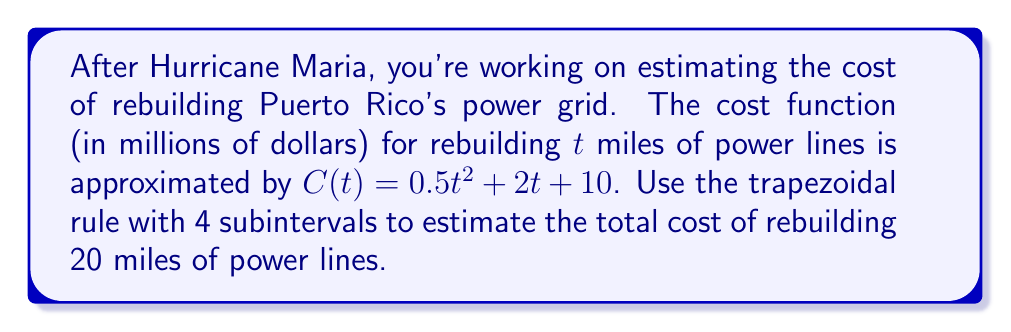Can you answer this question? 1) The trapezoidal rule for numerical integration is given by:

   $$\int_{a}^{b} f(x) dx \approx \frac{h}{2}[f(x_0) + 2f(x_1) + 2f(x_2) + ... + 2f(x_{n-1}) + f(x_n)]$$

   where $h = \frac{b-a}{n}$, and $n$ is the number of subintervals.

2) In this case, $a=0$, $b=20$, and $n=4$. So, $h = \frac{20-0}{4} = 5$.

3) We need to calculate $C(t)$ at $t = 0, 5, 10, 15, 20$:

   $C(0) = 0.5(0)^2 + 2(0) + 10 = 10$
   $C(5) = 0.5(5)^2 + 2(5) + 10 = 32.5$
   $C(10) = 0.5(10)^2 + 2(10) + 10 = 80$
   $C(15) = 0.5(15)^2 + 2(15) + 10 = 152.5$
   $C(20) = 0.5(20)^2 + 2(20) + 10 = 250$

4) Applying the trapezoidal rule:

   $$\text{Total Cost} \approx \frac{5}{2}[10 + 2(32.5) + 2(80) + 2(152.5) + 250]$$

5) Simplifying:
   $$\text{Total Cost} \approx \frac{5}{2}[10 + 65 + 160 + 305 + 250]$$
   $$\text{Total Cost} \approx \frac{5}{2}[790] = 1975$$

Therefore, the estimated total cost of rebuilding 20 miles of power lines is $1975 million.
Answer: $1975 million 